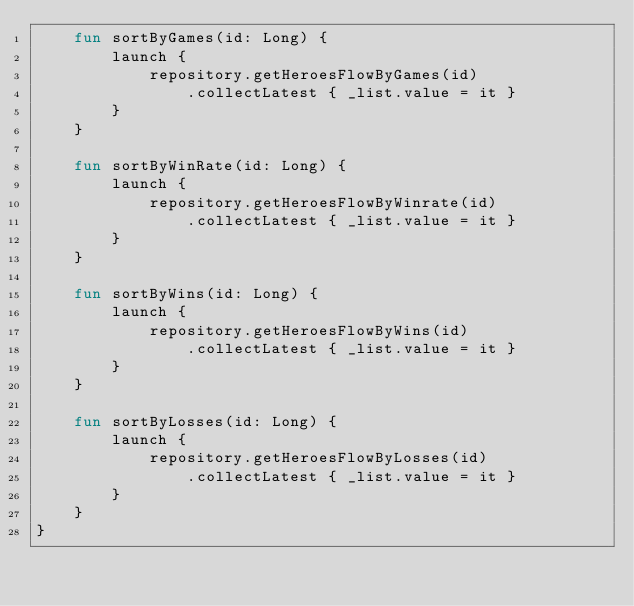<code> <loc_0><loc_0><loc_500><loc_500><_Kotlin_>    fun sortByGames(id: Long) {
        launch {
            repository.getHeroesFlowByGames(id)
                .collectLatest { _list.value = it }
        }
    }

    fun sortByWinRate(id: Long) {
        launch {
            repository.getHeroesFlowByWinrate(id)
                .collectLatest { _list.value = it }
        }
    }

    fun sortByWins(id: Long) {
        launch {
            repository.getHeroesFlowByWins(id)
                .collectLatest { _list.value = it }
        }
    }

    fun sortByLosses(id: Long) {
        launch {
            repository.getHeroesFlowByLosses(id)
                .collectLatest { _list.value = it }
        }
    }
}</code> 